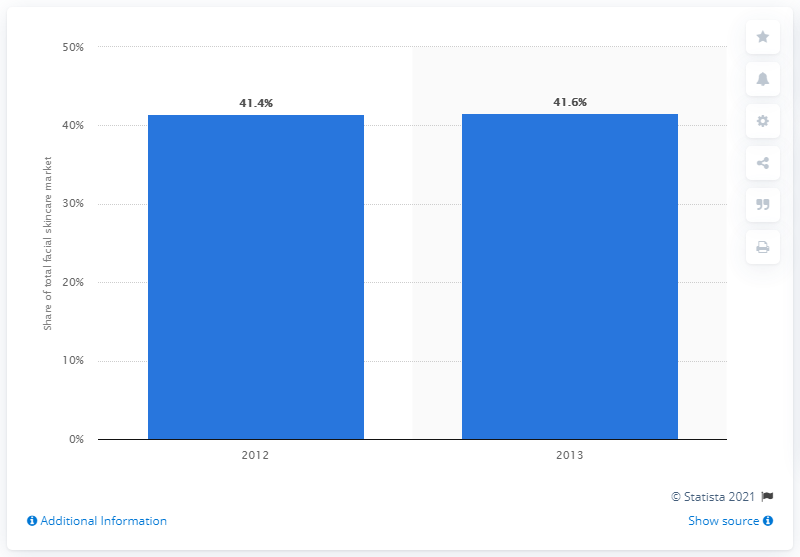Identify some key points in this picture. In 2013, anti-aging products accounted for 41.6% of the facial skin care market. 